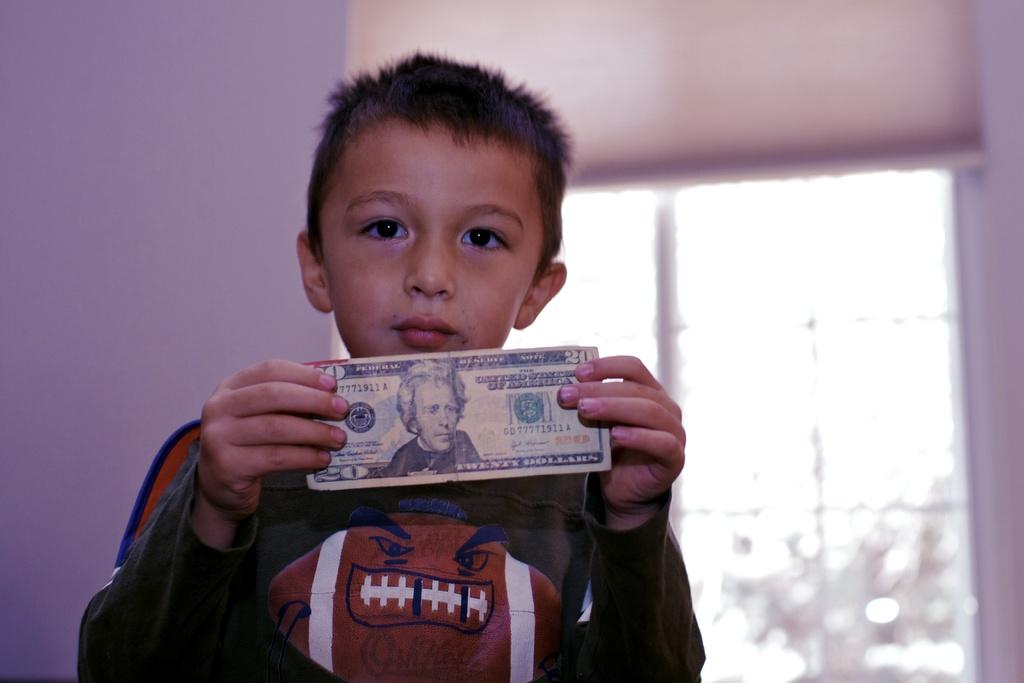What is the value of the bill the boy is holding?
Keep it short and to the point. 20. How much is that boy holding?
Offer a terse response. 20 dollars. 